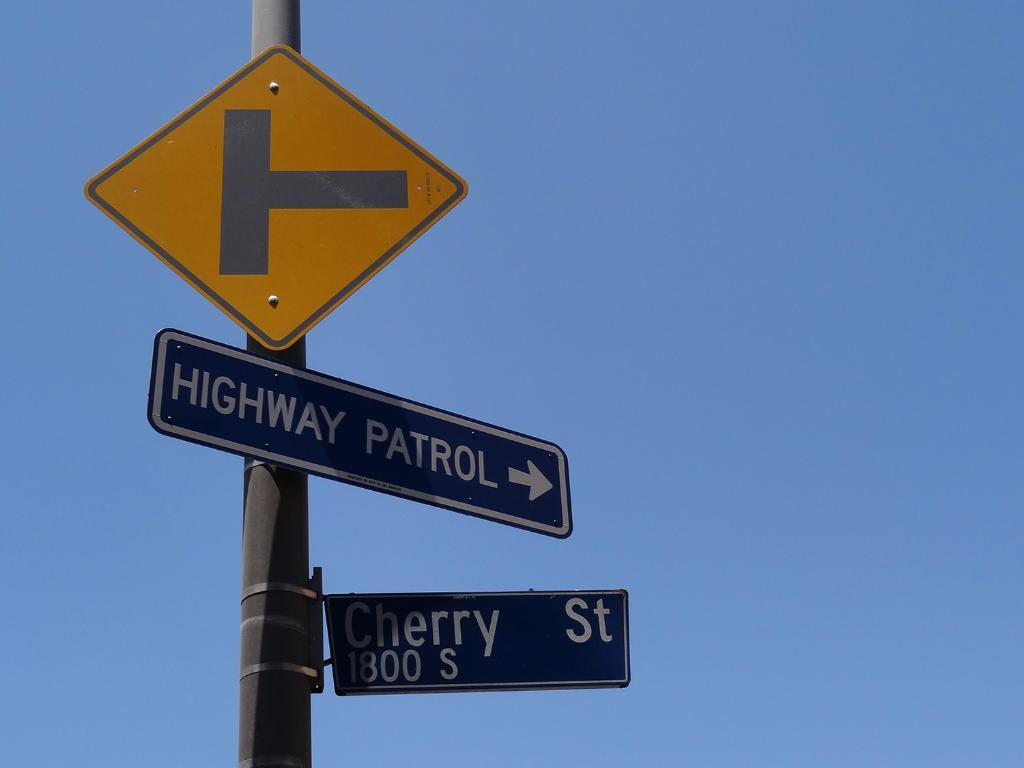Provide a one-sentence caption for the provided image. The intersection of Cherry Street shows where Highway Patrol is located. 